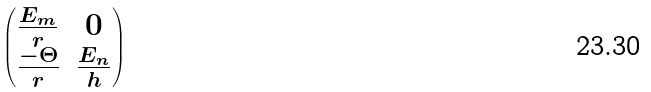Convert formula to latex. <formula><loc_0><loc_0><loc_500><loc_500>\begin{pmatrix} \frac { E _ { m } } { r } & 0 \\ \frac { - \Theta } { r } & \frac { E _ { n } } { h } \end{pmatrix}</formula> 